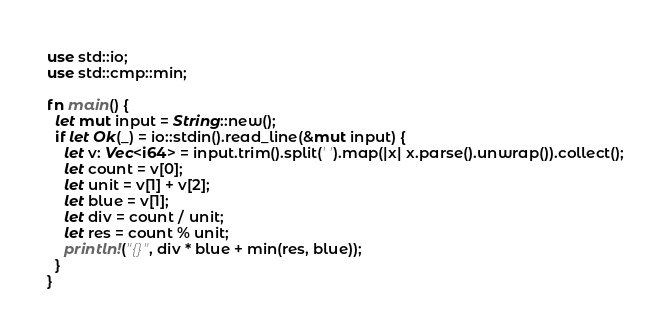<code> <loc_0><loc_0><loc_500><loc_500><_Rust_>use std::io;
use std::cmp::min;

fn main() {
  let mut input = String::new();
  if let Ok(_) = io::stdin().read_line(&mut input) {
    let v: Vec<i64> = input.trim().split(' ').map(|x| x.parse().unwrap()).collect();
    let count = v[0];
    let unit = v[1] + v[2];
    let blue = v[1];
    let div = count / unit;
    let res = count % unit;
    println!("{}", div * blue + min(res, blue));
  }
}</code> 